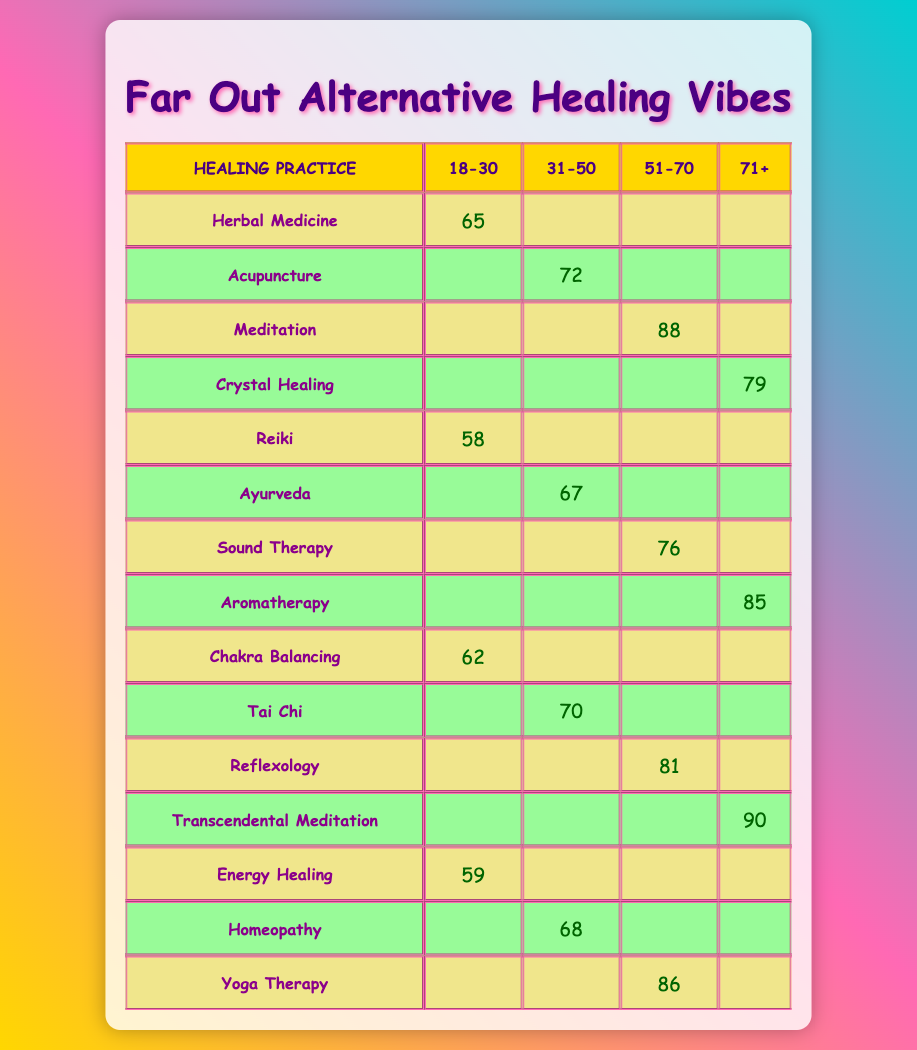What is the popularity score of Herbal Medicine for the age group 18-30? The score for Herbal Medicine in the age group 18-30 is directly provided in the table as 65.
Answer: 65 Which alternative healing practice has the highest popularity score among the 71+ age group? Looking at the 71+ age group, the practices are Crystal Healing with 79, Aromatherapy with 85, and Transcendental Meditation with 90. The highest score is 90 for Transcendental Meditation.
Answer: Transcendental Meditation Is the popularity score for Yoga Therapy higher than that for Acupuncture? Yoga Therapy's score is 86, while Acupuncture's score is 72. Since 86 is greater than 72, the statement is true.
Answer: Yes What healing practice shows the greatest difference in scores between the 51-70 and 31-50 age groups? The scores for 51-70 age group for Reflexology (81) and for 31-50 for Acupuncture (72) show a difference of 9. Other differences are smaller. The greatest is for Reflexology with a difference of 9.
Answer: Reflexology What is the average popularity score for the age group 18-30? The scores for 18-30 are 65 (Herbal Medicine), 58 (Reiki), 62 (Chakra Balancing), and 59 (Energy Healing). The sum is 65 + 58 + 62 + 59 = 244. There are 4 practices, so the average is 244 / 4 = 61.
Answer: 61 Which age group has the lowest total popularity score when combined across all healing practices? Taking the total scores for each group: 18-30 (65 + 58 + 62 + 59 = 244), 31-50 (72 + 67 + 70 + 68 = 277), 51-70 (88 + 76 + 81 + 86 = 331), and 71+ (79 + 85 + 90 = 254). The age group with the lowest score is 18-30 with a score of 244.
Answer: 18-30 